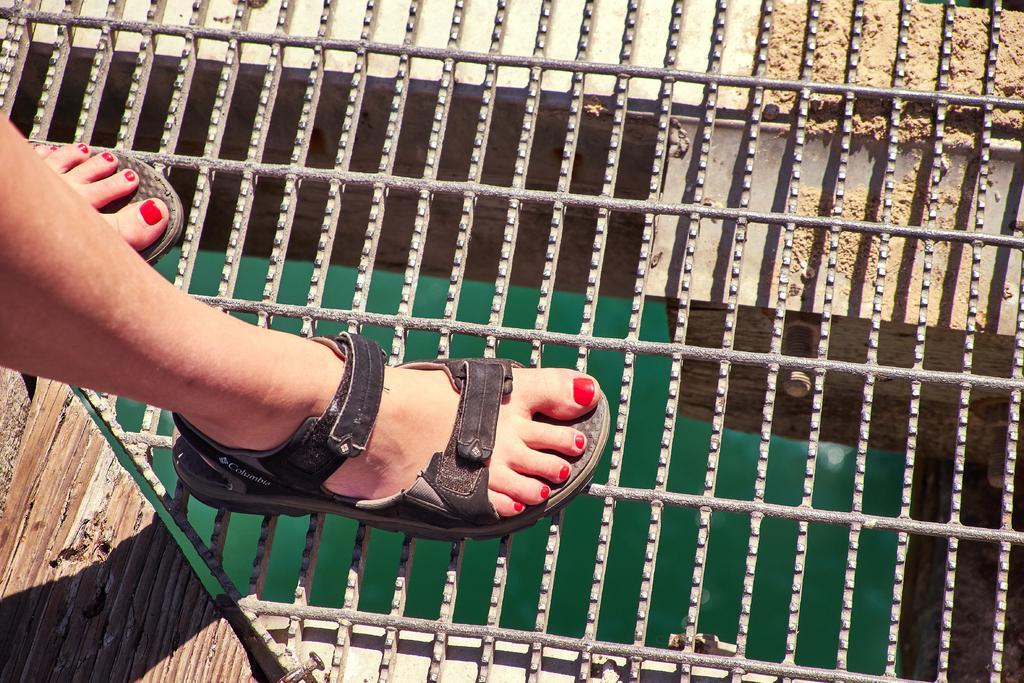Could you give a brief overview of what you see in this image? In this image in the front there is a person standing on iron rods. On the left side there is a wooden surface. Under the iron rods there is an object which is green in colour. 